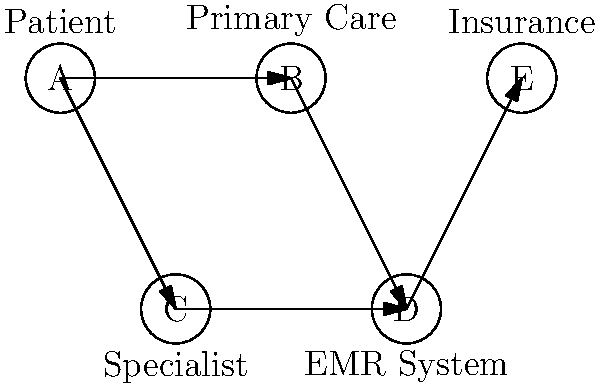In the directed graph representing a telemedicine system, what is the minimum number of edges that medical information must traverse to reach the insurance company (node E) from the patient (node A)? To determine the minimum number of edges that medical information must traverse from the patient (node A) to the insurance company (node E), we need to analyze the possible paths in the directed graph:

1. Start at node A (Patient)
2. From A, we have two possible paths:
   a. A → B (Primary Care)
   b. A → C (Specialist)
3. Both paths then lead to D (EMR System):
   a. A → B → D
   b. A → C → D
4. From D, there is only one path to E (Insurance):
   D → E

5. Counting the edges in each possible path:
   Path 1: A → B → D → E (3 edges)
   Path 2: A → C → D → E (3 edges)

6. Both paths have the same number of edges (3), which is the minimum number of edges required to reach E from A.

Therefore, the minimum number of edges that medical information must traverse to reach the insurance company from the patient is 3.
Answer: 3 edges 